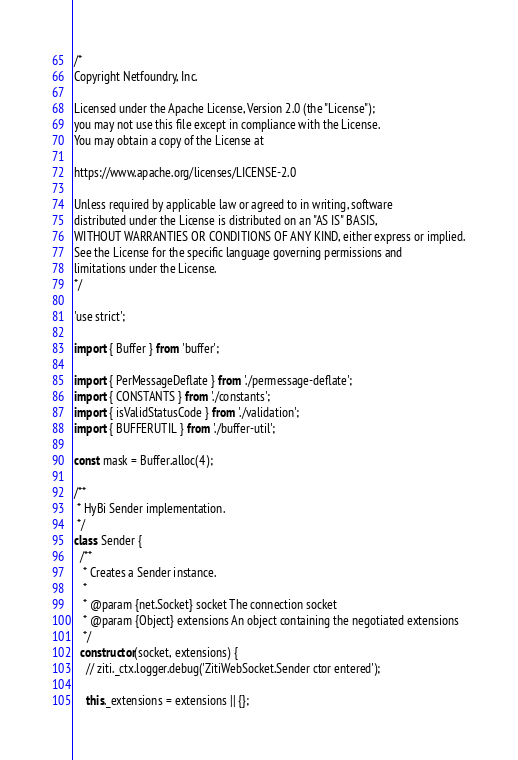<code> <loc_0><loc_0><loc_500><loc_500><_JavaScript_>/*
Copyright Netfoundry, Inc.

Licensed under the Apache License, Version 2.0 (the "License");
you may not use this file except in compliance with the License.
You may obtain a copy of the License at

https://www.apache.org/licenses/LICENSE-2.0

Unless required by applicable law or agreed to in writing, software
distributed under the License is distributed on an "AS IS" BASIS,
WITHOUT WARRANTIES OR CONDITIONS OF ANY KIND, either express or implied.
See the License for the specific language governing permissions and
limitations under the License.
*/

'use strict';

import { Buffer } from 'buffer';

import { PerMessageDeflate } from './permessage-deflate';
import { CONSTANTS } from './constants';
import { isValidStatusCode } from './validation';
import { BUFFERUTIL } from './buffer-util';

const mask = Buffer.alloc(4);

/**
 * HyBi Sender implementation.
 */
class Sender {
  /**
   * Creates a Sender instance.
   *
   * @param {net.Socket} socket The connection socket
   * @param {Object} extensions An object containing the negotiated extensions
   */
  constructor(socket, extensions) {
    // ziti._ctx.logger.debug('ZitiWebSocket.Sender ctor entered');

    this._extensions = extensions || {};</code> 